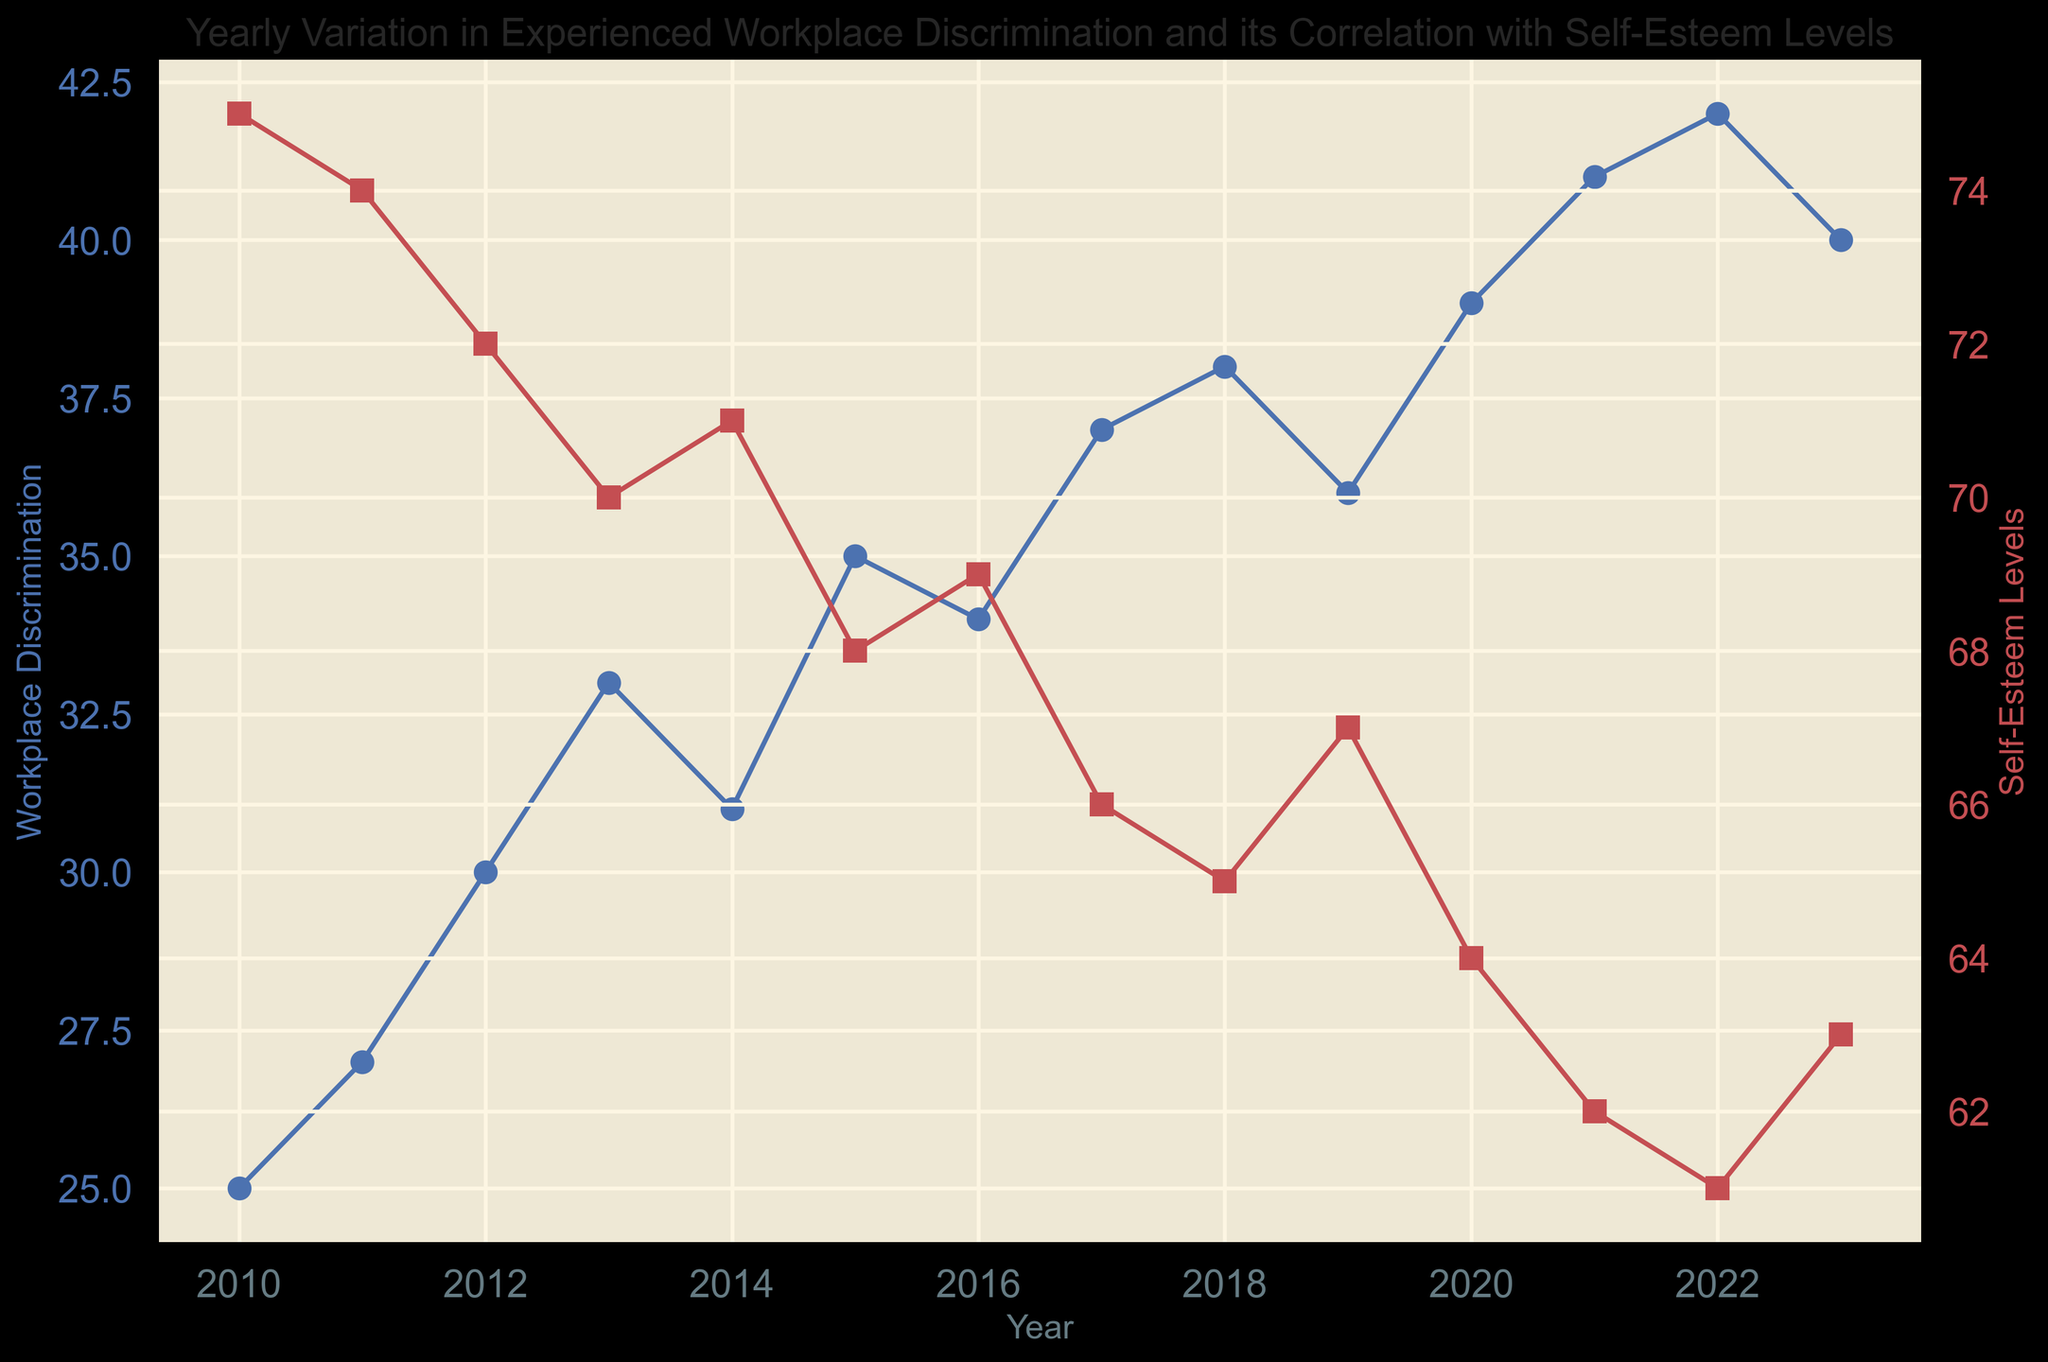what's the trend of Workplace Discrimination from 2010 to 2023? To determine the trend of Workplace Discrimination, observe the line representing its values from 2010 to 2023. The values consistently increase with some minor fluctuations. Specifically, the values start from 25 in 2010 and generally rise, peaking at 42 in 2022 and slightly dropping to 40 in 2023.
Answer: Increasing with minor fluctuations what is the range of Self-Esteem Levels observed from 2010 to 2023? To find the range, identify the highest and lowest values of Self-Esteem Levels. The highest value is 75 in 2010, and the lowest value is 61 in 2022. The range is the difference between these values. So, 75 - 61 = 14.
Answer: 14 how does the increase in Workplace Discrimination between 2018 and 2022 correlate with Self-Esteem Levels? From 2018 to 2022, Workplace Discrimination increases from 38 to 42. During the same period, Self-Esteem Levels decrease from 65 to 61. This suggests a negative correlation: as Workplace Discrimination increases, Self-Esteem Levels decrease.
Answer: Negative correlation which year had the greatest decrease in Self-Esteem Levels compared to the previous year? Compare the year-over-year differences in Self-Esteem Levels. The largest decrease occurred from 2017 (66) to 2018 (65), 2018 (65) to 2019 (67), but the most significant drop is from 2020 (64) to 2021 (62), a decrease of 2 units.
Answer: 2021 by how much did Workplace Discrimination increase from 2010 to 2023? Calculate the difference between the Workplace Discrimination values in 2010 (25) and 2023 (40). So, 40 - 25 = 15.
Answer: 15 what was the lowest level of Self-Esteem, and when did it occur? Identify the lowest point on the Self-Esteem Levels plot. The lowest value is 61, which occurred in 2022.
Answer: 61 in 2022 during which year was the gap between Workplace Discrimination and Self-Esteem Levels the smallest? Compare the difference between Workplace Discrimination and Self-Esteem Levels for each year. The smallest gap is found by checking the differences year by year. For 2010: 50, for 2011: 47, ..., for 2023: 23. The smallest gap of 23 occurred in 2023.
Answer: 2023 what was the Workplace Discrimination level in the year when Self-Esteem Levels reached their minimum? Find the year when the Self-Esteem Levels were at their minimum (2022) and then check the corresponding Workplace Discrimination value for that year (42).
Answer: 42 is the overall trend of Self-Esteem Levels upwards or downwards from 2010 to 2023? Observe the line for Self-Esteem Levels from 2010 to 2023. The trend starts at 75 in 2010 and generally decreases to 63 in 2023. This indicates a downward trend.
Answer: Downward compare the change in Workplace Discrimination and Self-Esteem Levels from 2015 to 2020. From 2015 to 2020, Workplace Discrimination increased from 35 to 39, a change of +4. During the same period, Self-Esteem Levels decreased from 68 to 64, a change of -4.
Answer: Workplace Discrimination +4, Self-Esteem Levels -4 